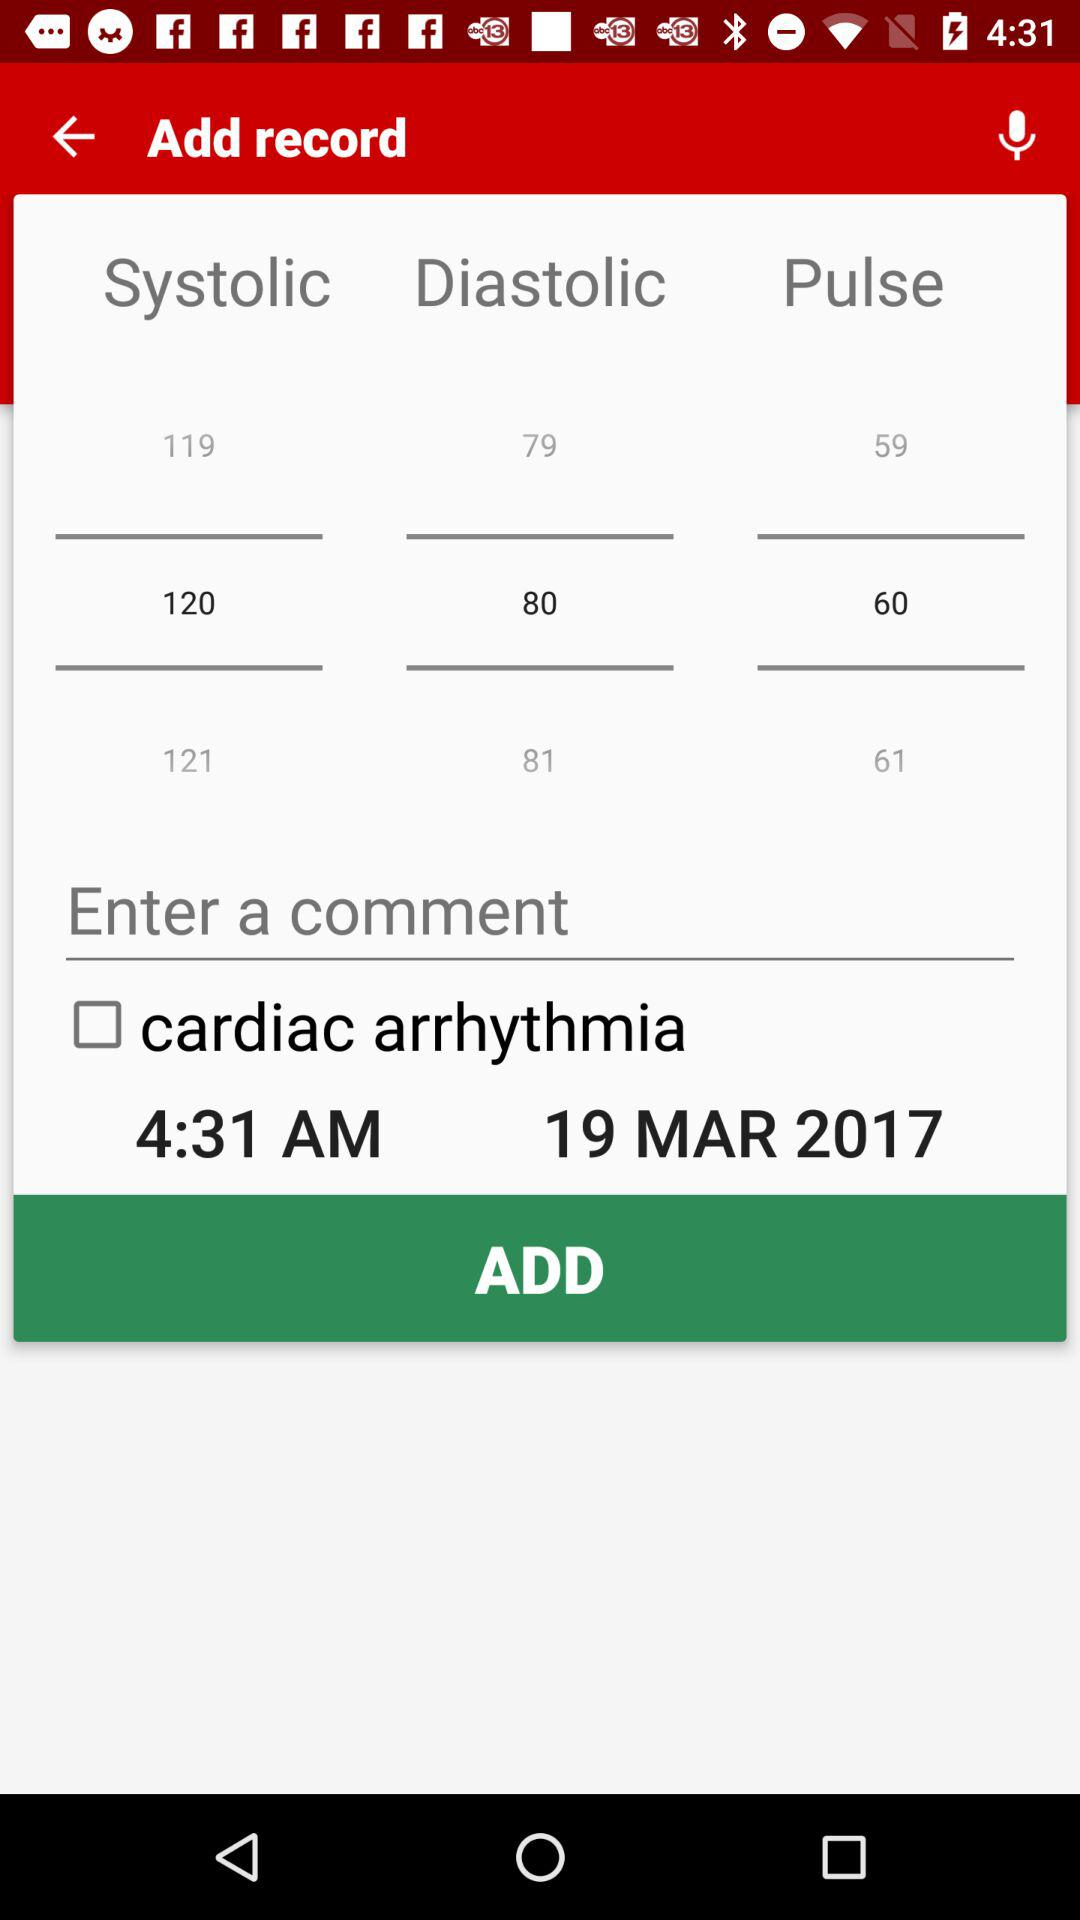What time is mentioned on the screen? The mentioned time on the screen is 4:31 AM. 